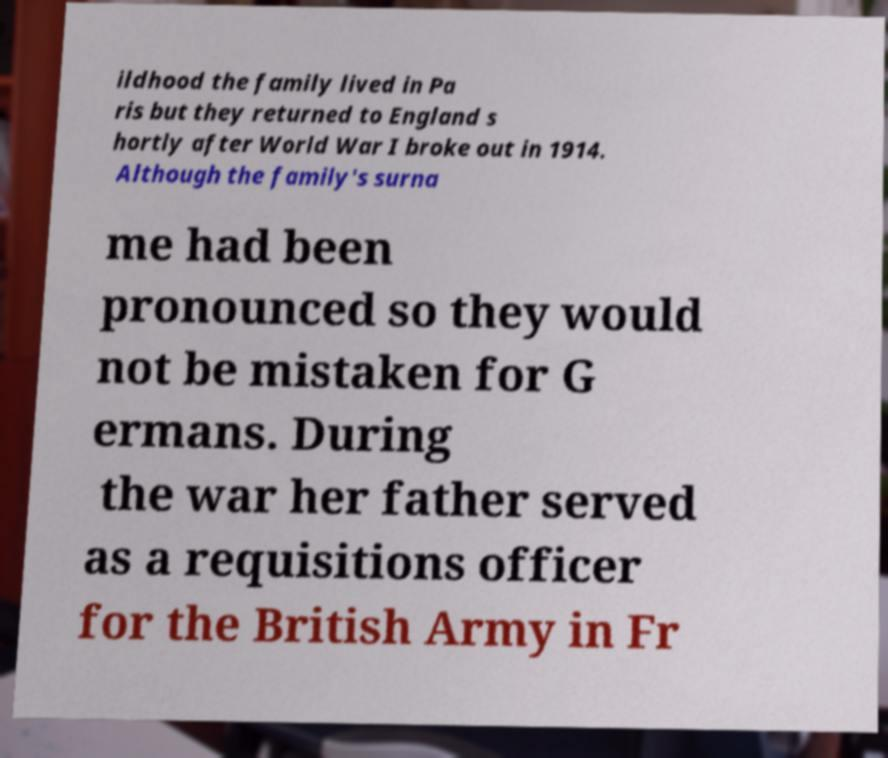I need the written content from this picture converted into text. Can you do that? ildhood the family lived in Pa ris but they returned to England s hortly after World War I broke out in 1914. Although the family's surna me had been pronounced so they would not be mistaken for G ermans. During the war her father served as a requisitions officer for the British Army in Fr 